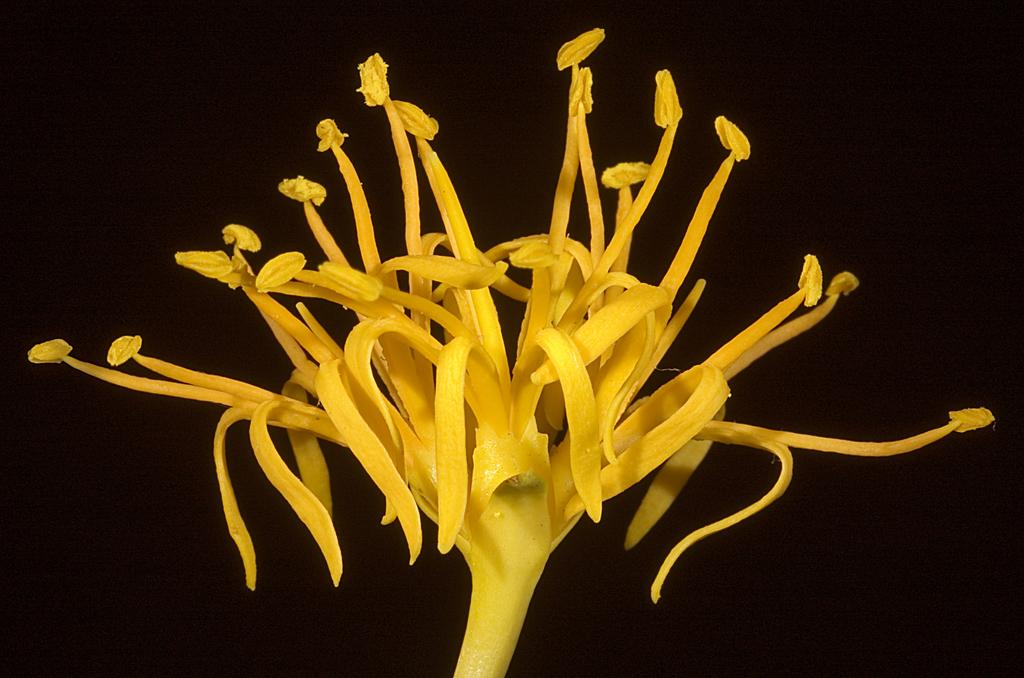What type of flower is in the image? There is a yellow flower in the image. What color is the background of the image? The background of the image is black. What type of bells can be heard ringing in the image? There are no bells present in the image, and therefore no sound can be heard. 